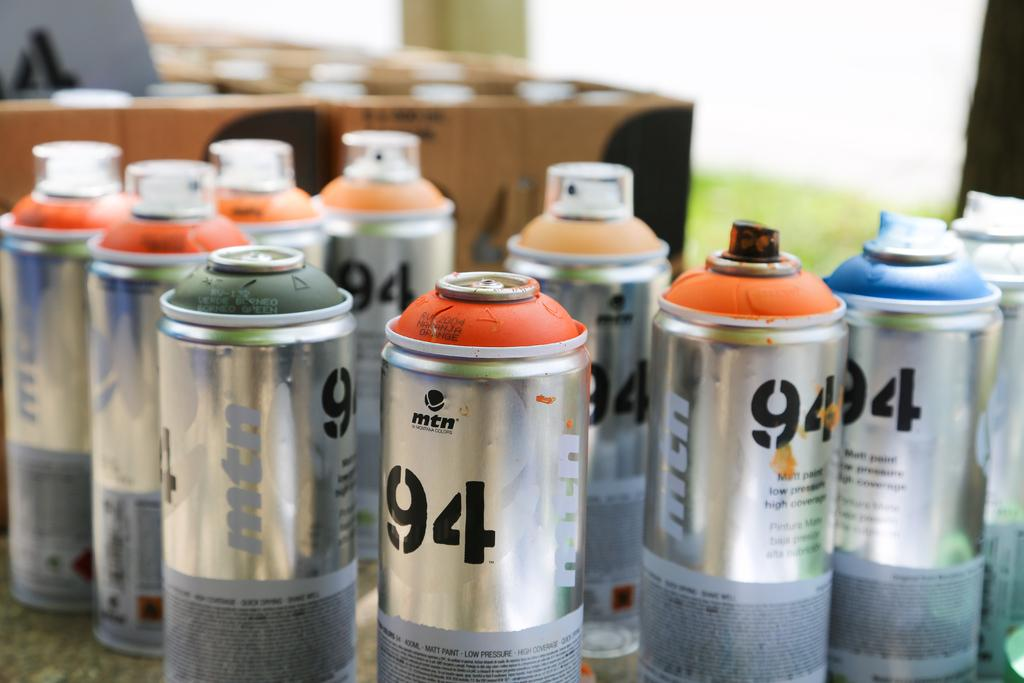<image>
Share a concise interpretation of the image provided. Bunch of spray cans that have the number 94 on it. 